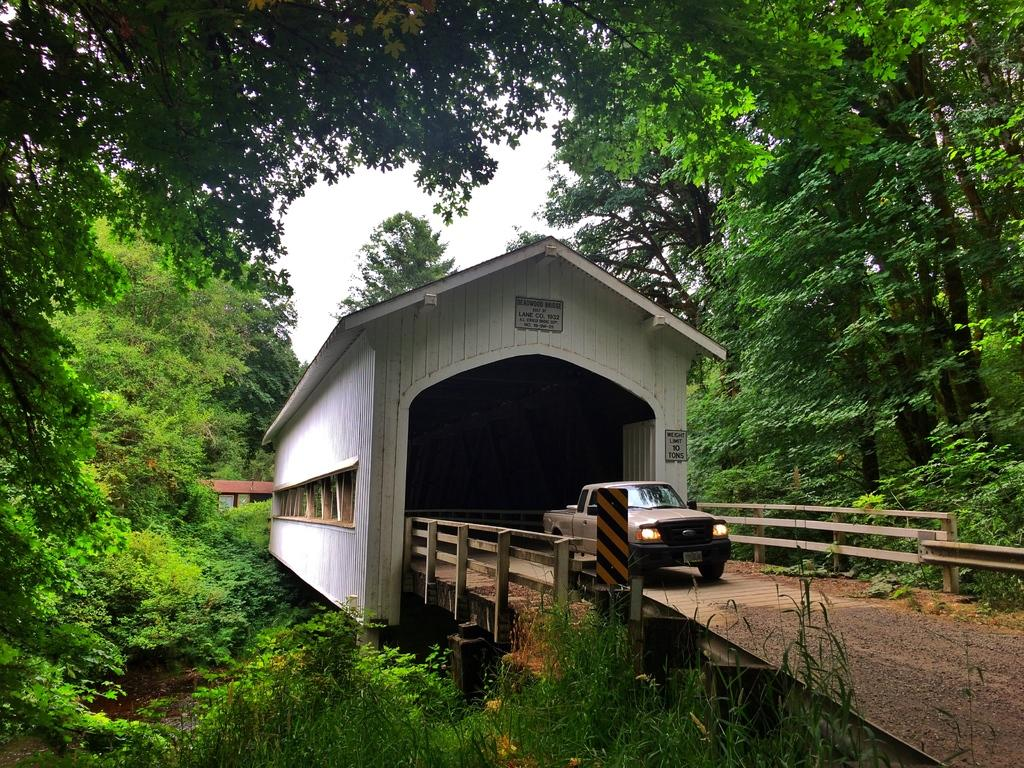What is the main subject of the image? There is a car in the image. Where is the car located? The car is on a bridge. What type of natural elements can be seen in the image? Trees and bushes are visible in the image. What type of shop can be seen in the image? There is no shop present in the image; it features a car on a bridge with trees and bushes in the background. Can you tell me how many bats are hanging from the trees in the image? There are no bats visible in the image; only trees and bushes are present. 